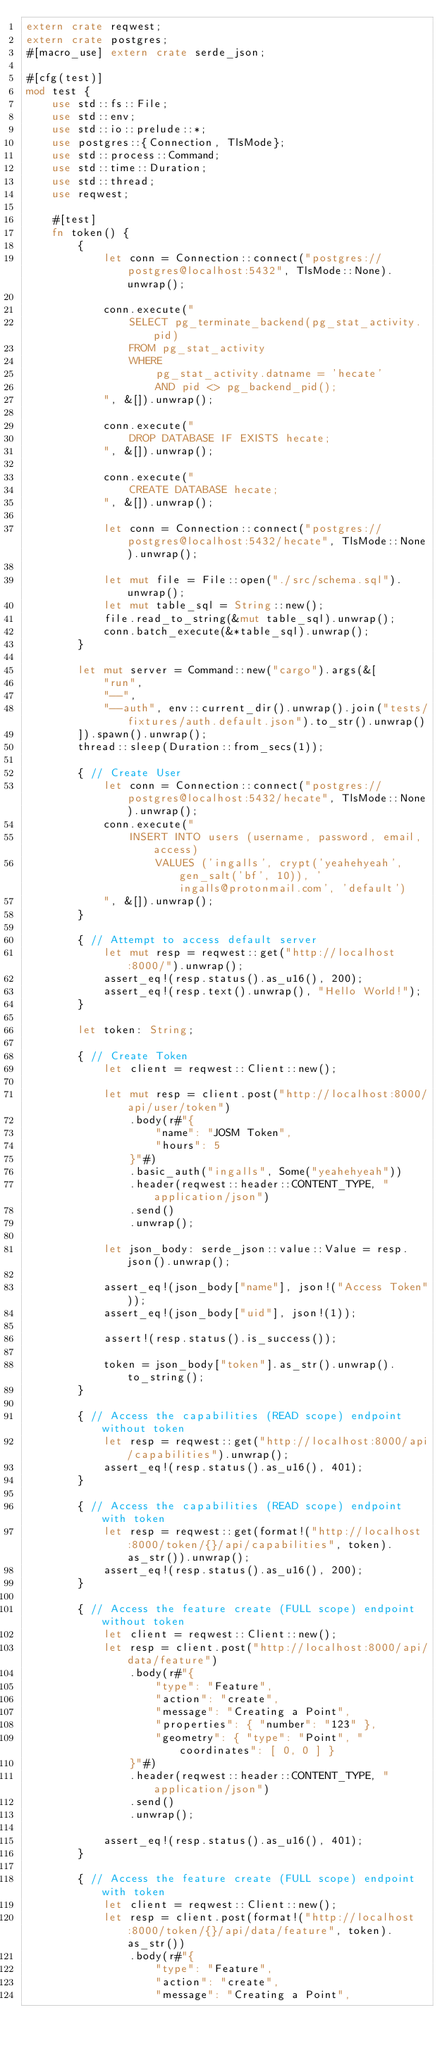Convert code to text. <code><loc_0><loc_0><loc_500><loc_500><_Rust_>extern crate reqwest;
extern crate postgres;
#[macro_use] extern crate serde_json;

#[cfg(test)]
mod test {
    use std::fs::File;
    use std::env;
    use std::io::prelude::*;
    use postgres::{Connection, TlsMode};
    use std::process::Command;
    use std::time::Duration;
    use std::thread;
    use reqwest;

    #[test]
    fn token() {
        {
            let conn = Connection::connect("postgres://postgres@localhost:5432", TlsMode::None).unwrap();

            conn.execute("
                SELECT pg_terminate_backend(pg_stat_activity.pid)
                FROM pg_stat_activity
                WHERE
                    pg_stat_activity.datname = 'hecate'
                    AND pid <> pg_backend_pid();
            ", &[]).unwrap();

            conn.execute("
                DROP DATABASE IF EXISTS hecate;
            ", &[]).unwrap();

            conn.execute("
                CREATE DATABASE hecate;
            ", &[]).unwrap();

            let conn = Connection::connect("postgres://postgres@localhost:5432/hecate", TlsMode::None).unwrap();

            let mut file = File::open("./src/schema.sql").unwrap();
            let mut table_sql = String::new();
            file.read_to_string(&mut table_sql).unwrap();
            conn.batch_execute(&*table_sql).unwrap();
        }

        let mut server = Command::new("cargo").args(&[
            "run",
            "--",
            "--auth", env::current_dir().unwrap().join("tests/fixtures/auth.default.json").to_str().unwrap()
        ]).spawn().unwrap();
        thread::sleep(Duration::from_secs(1));

        { // Create User
            let conn = Connection::connect("postgres://postgres@localhost:5432/hecate", TlsMode::None).unwrap();
            conn.execute("
                INSERT INTO users (username, password, email, access)
                    VALUES ('ingalls', crypt('yeahehyeah', gen_salt('bf', 10)), 'ingalls@protonmail.com', 'default')
            ", &[]).unwrap();
        }

        { // Attempt to access default server
            let mut resp = reqwest::get("http://localhost:8000/").unwrap();
            assert_eq!(resp.status().as_u16(), 200);
            assert_eq!(resp.text().unwrap(), "Hello World!");
        }

        let token: String;

        { // Create Token
            let client = reqwest::Client::new();

            let mut resp = client.post("http://localhost:8000/api/user/token")
                .body(r#"{
                    "name": "JOSM Token",
                    "hours": 5
                }"#)
                .basic_auth("ingalls", Some("yeahehyeah"))
                .header(reqwest::header::CONTENT_TYPE, "application/json")
                .send()
                .unwrap();

            let json_body: serde_json::value::Value = resp.json().unwrap();

            assert_eq!(json_body["name"], json!("Access Token"));
            assert_eq!(json_body["uid"], json!(1));

            assert!(resp.status().is_success());

            token = json_body["token"].as_str().unwrap().to_string();
        }

        { // Access the capabilities (READ scope) endpoint without token
            let resp = reqwest::get("http://localhost:8000/api/capabilities").unwrap();
            assert_eq!(resp.status().as_u16(), 401);
        }

        { // Access the capabilities (READ scope) endpoint with token
            let resp = reqwest::get(format!("http://localhost:8000/token/{}/api/capabilities", token).as_str()).unwrap();
            assert_eq!(resp.status().as_u16(), 200);
        }

        { // Access the feature create (FULL scope) endpoint without token
            let client = reqwest::Client::new();
            let resp = client.post("http://localhost:8000/api/data/feature")
                .body(r#"{
                    "type": "Feature",
                    "action": "create",
                    "message": "Creating a Point",
                    "properties": { "number": "123" },
                    "geometry": { "type": "Point", "coordinates": [ 0, 0 ] }
                }"#)
                .header(reqwest::header::CONTENT_TYPE, "application/json")
                .send()
                .unwrap();

            assert_eq!(resp.status().as_u16(), 401);
        }

        { // Access the feature create (FULL scope) endpoint with token
            let client = reqwest::Client::new();
            let resp = client.post(format!("http://localhost:8000/token/{}/api/data/feature", token).as_str())
                .body(r#"{
                    "type": "Feature",
                    "action": "create",
                    "message": "Creating a Point",</code> 